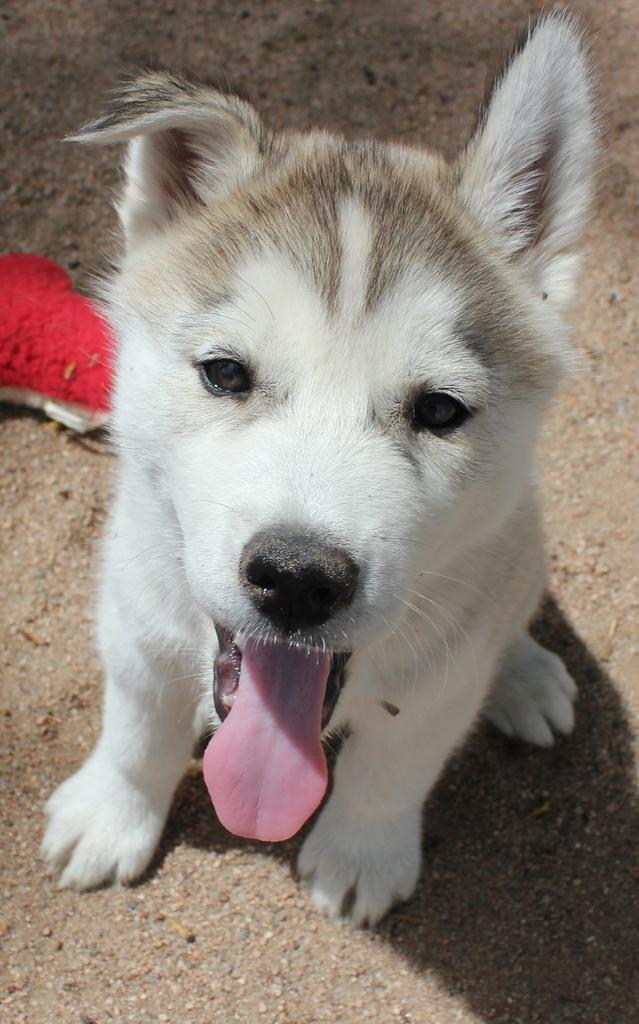Could you give a brief overview of what you see in this image? In the center of the image a dog is there. On the left side of the image we can see an object. In the background of the image we can see the ground. 